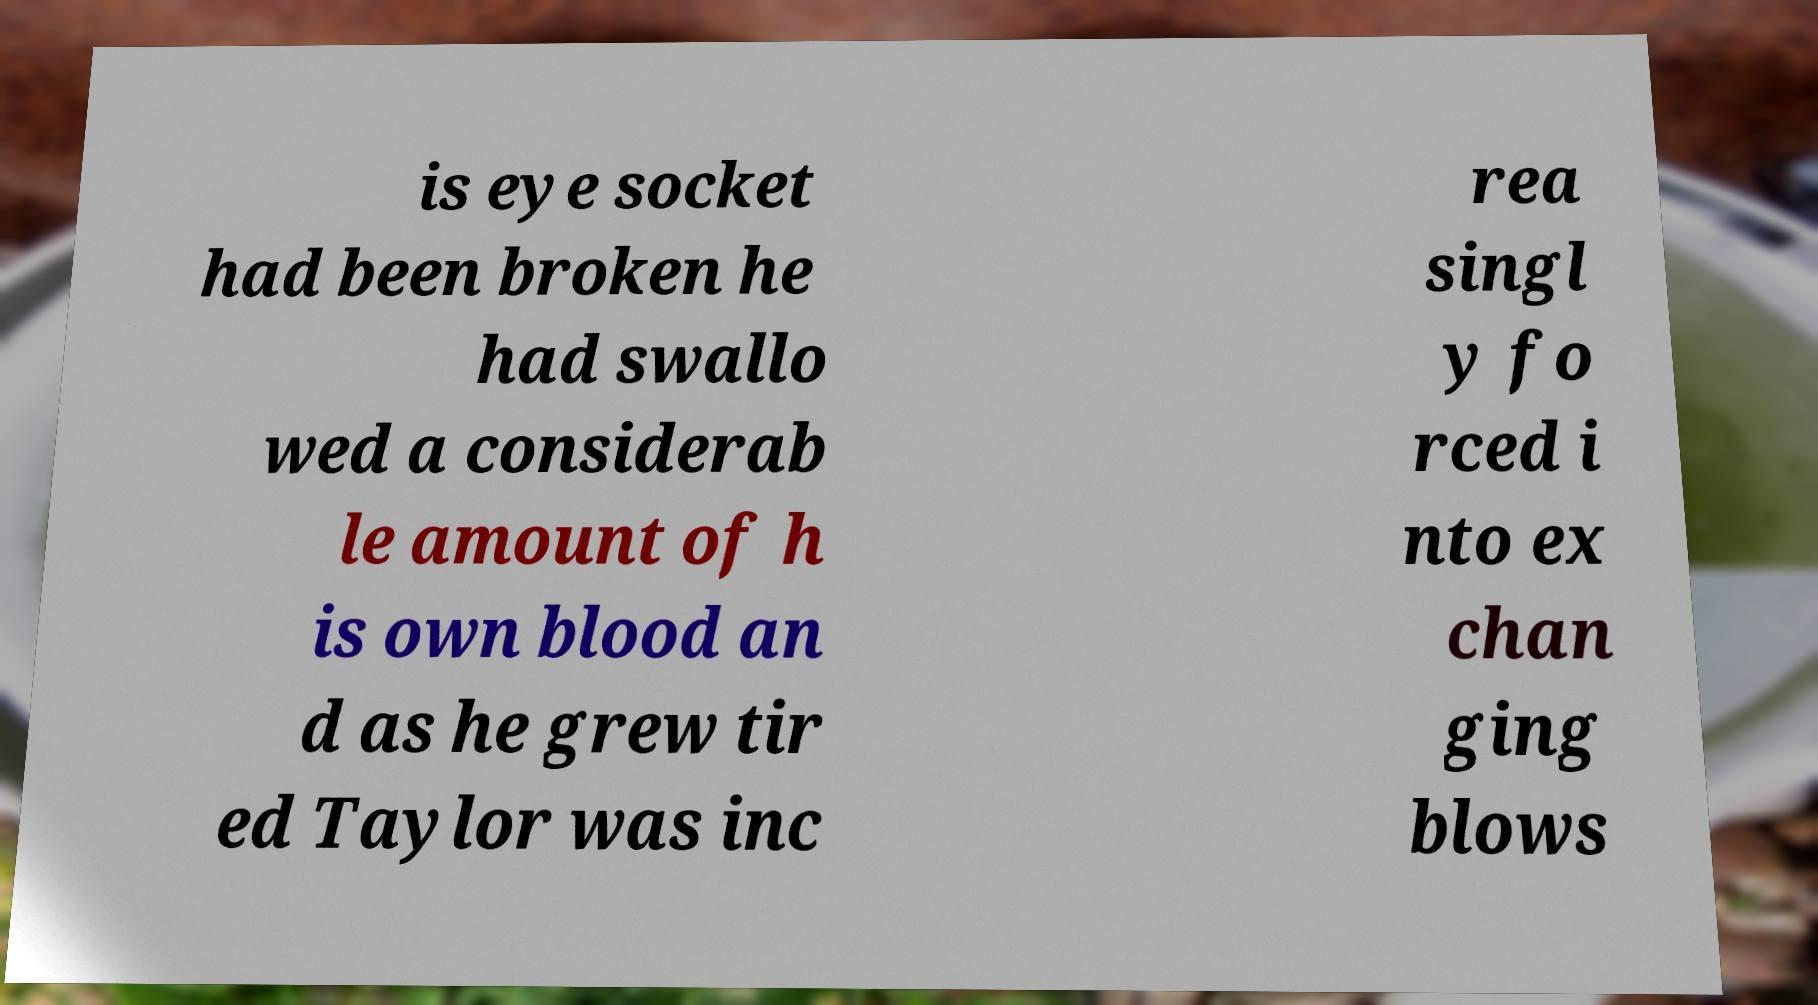Can you accurately transcribe the text from the provided image for me? is eye socket had been broken he had swallo wed a considerab le amount of h is own blood an d as he grew tir ed Taylor was inc rea singl y fo rced i nto ex chan ging blows 